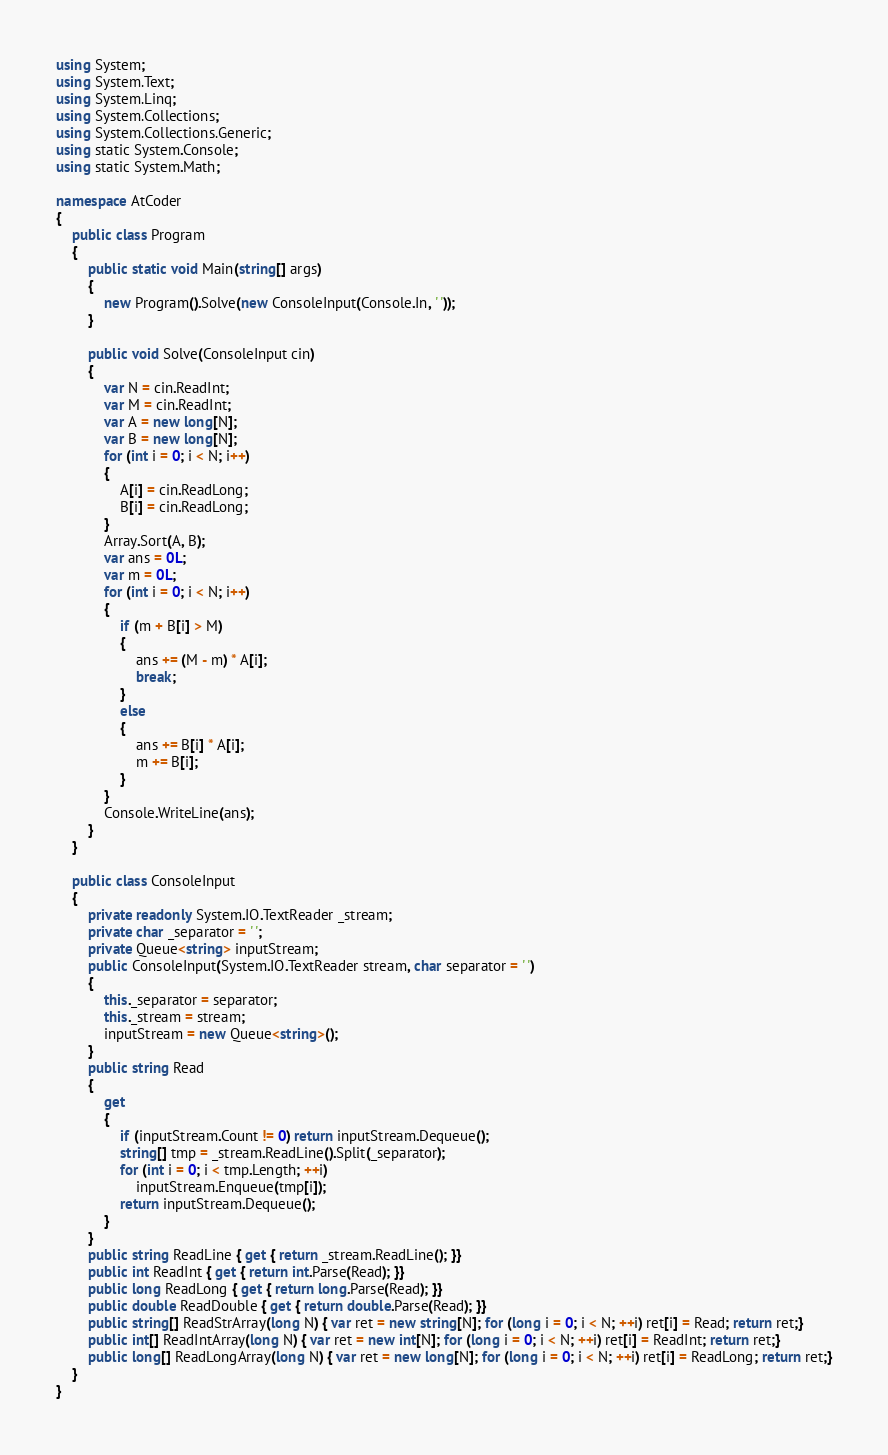Convert code to text. <code><loc_0><loc_0><loc_500><loc_500><_C#_>using System;
using System.Text;
using System.Linq;
using System.Collections;
using System.Collections.Generic;
using static System.Console;
using static System.Math;

namespace AtCoder
{
    public class Program
    {
        public static void Main(string[] args)
        {
            new Program().Solve(new ConsoleInput(Console.In, ' '));
        }

        public void Solve(ConsoleInput cin)
        {
            var N = cin.ReadInt;
            var M = cin.ReadInt;
            var A = new long[N];
            var B = new long[N];
            for (int i = 0; i < N; i++)
            {
                A[i] = cin.ReadLong;
                B[i] = cin.ReadLong;
            }
            Array.Sort(A, B);
            var ans = 0L;
            var m = 0L;
            for (int i = 0; i < N; i++)
            {
                if (m + B[i] > M)
                {
                    ans += (M - m) * A[i];
                    break;
                }
                else
                {
                    ans += B[i] * A[i];
                    m += B[i];
                }
            }
            Console.WriteLine(ans);
        }
    }

    public class ConsoleInput
    {
        private readonly System.IO.TextReader _stream;
        private char _separator = ' ';
        private Queue<string> inputStream;
        public ConsoleInput(System.IO.TextReader stream, char separator = ' ')
        {
            this._separator = separator;
            this._stream = stream;
            inputStream = new Queue<string>();
        }
        public string Read
        {
            get
            {
                if (inputStream.Count != 0) return inputStream.Dequeue();
                string[] tmp = _stream.ReadLine().Split(_separator);
                for (int i = 0; i < tmp.Length; ++i)
                    inputStream.Enqueue(tmp[i]);
                return inputStream.Dequeue();
            }
        }
        public string ReadLine { get { return _stream.ReadLine(); }}
        public int ReadInt { get { return int.Parse(Read); }}
        public long ReadLong { get { return long.Parse(Read); }}
        public double ReadDouble { get { return double.Parse(Read); }}
        public string[] ReadStrArray(long N) { var ret = new string[N]; for (long i = 0; i < N; ++i) ret[i] = Read; return ret;}
        public int[] ReadIntArray(long N) { var ret = new int[N]; for (long i = 0; i < N; ++i) ret[i] = ReadInt; return ret;}
        public long[] ReadLongArray(long N) { var ret = new long[N]; for (long i = 0; i < N; ++i) ret[i] = ReadLong; return ret;}
    }
}
</code> 